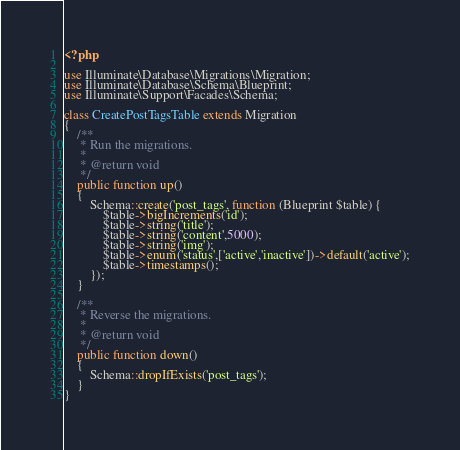<code> <loc_0><loc_0><loc_500><loc_500><_PHP_><?php

use Illuminate\Database\Migrations\Migration;
use Illuminate\Database\Schema\Blueprint;
use Illuminate\Support\Facades\Schema;

class CreatePostTagsTable extends Migration
{
    /**
     * Run the migrations.
     *
     * @return void
     */
    public function up()
    {
        Schema::create('post_tags', function (Blueprint $table) {
            $table->bigIncrements('id');
            $table->string('title');
            $table->string('content',5000);
            $table->string('img');
            $table->enum('status',['active','inactive'])->default('active');
            $table->timestamps();
        });
    }

    /**
     * Reverse the migrations.
     *
     * @return void
     */
    public function down()
    {
        Schema::dropIfExists('post_tags');
    }
}
</code> 